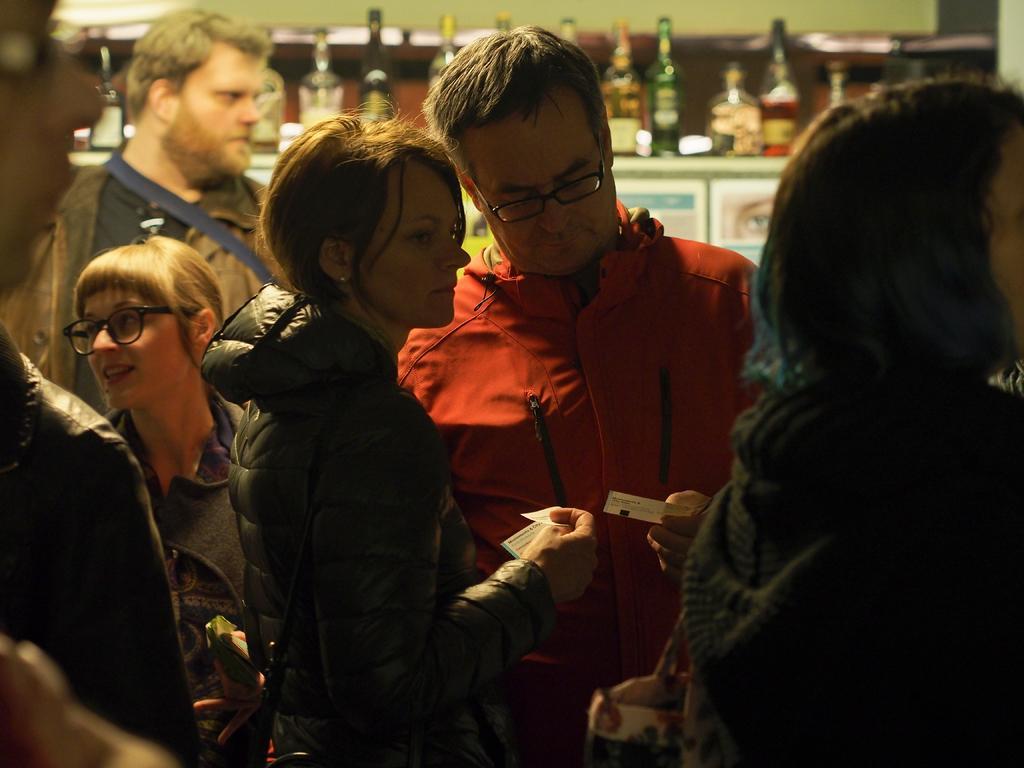Describe this image in one or two sentences. In this image, there are a few people. We can also see some bottles on an object. We can see the wall. 